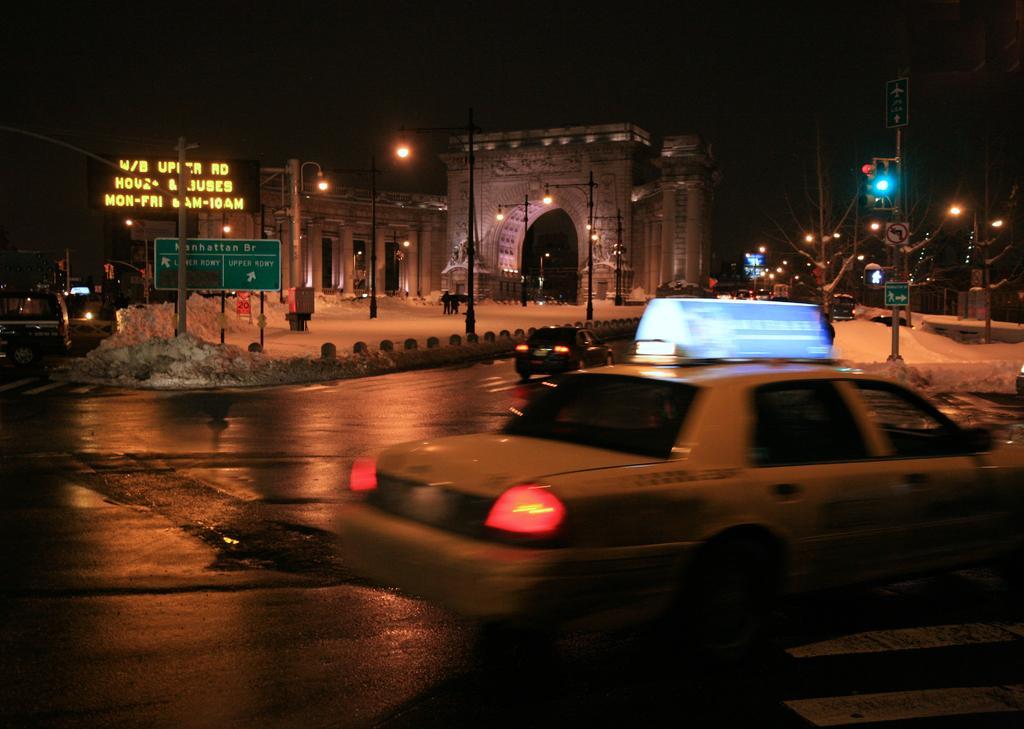Can you describe this image briefly? In this image I can see a road, on which I can see vehicles, poles, trees, signal lights and beside the road, I can see building, street light poles, persons visible in front of arch and arch is visible in the middle and there are some vehicles visible on the left side, at the top there is the sky and this picture is taken during night. 